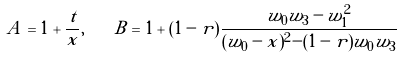Convert formula to latex. <formula><loc_0><loc_0><loc_500><loc_500>A = 1 + \frac { t } { x } , \quad B = 1 + ( 1 - r ) \frac { w _ { 0 } w _ { 3 } - w _ { 1 } ^ { 2 } } { ( w _ { 0 } - x ) ^ { 2 } - ( 1 - r ) w _ { 0 } w _ { 3 } }</formula> 